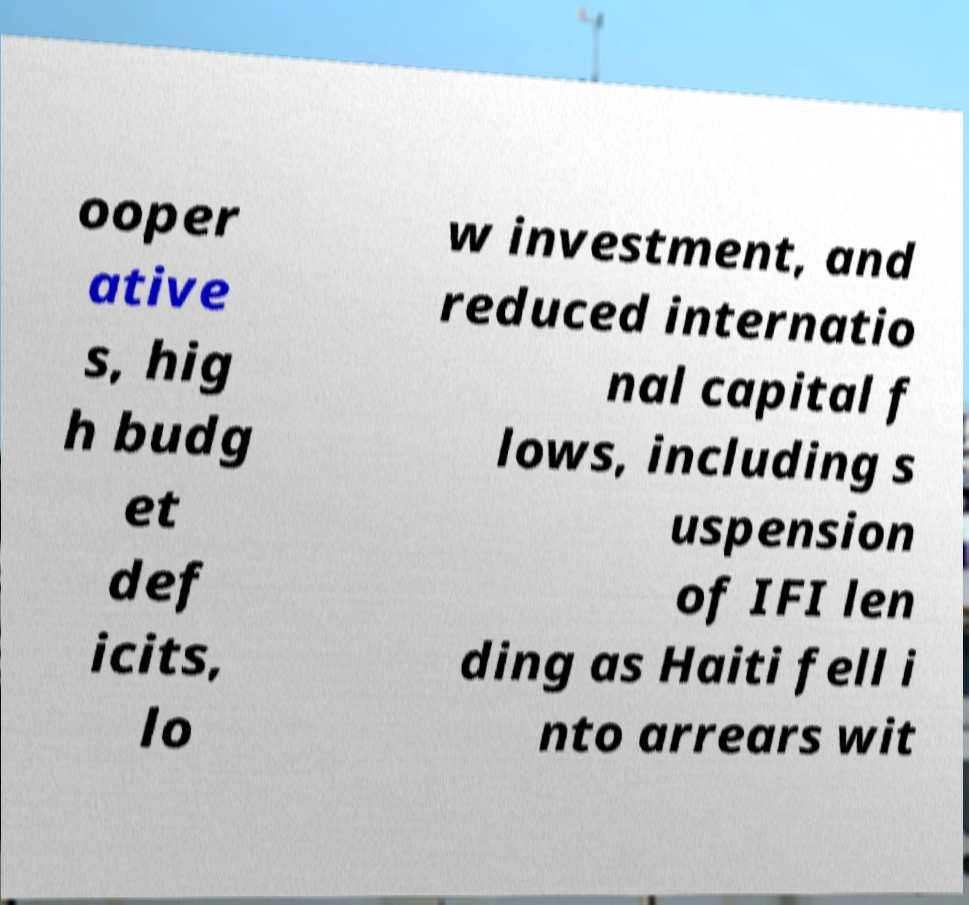For documentation purposes, I need the text within this image transcribed. Could you provide that? ooper ative s, hig h budg et def icits, lo w investment, and reduced internatio nal capital f lows, including s uspension of IFI len ding as Haiti fell i nto arrears wit 